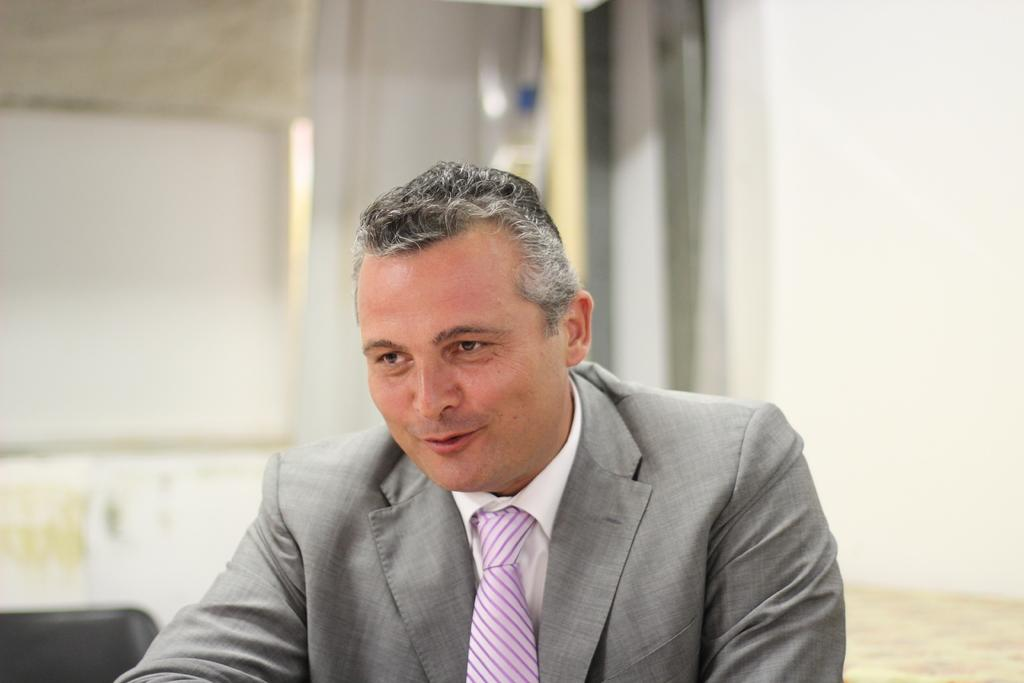Who is present in the image? There is a man in the image. What can be seen in the background of the image? There is a wall in the background of the image. How would you describe the background of the image? The background appears blurry. What type of skate is the man using in the image? There is no skate present in the image. Is there a fight happening between the man and someone else in the image? There is no indication of a fight or any conflict in the image. 